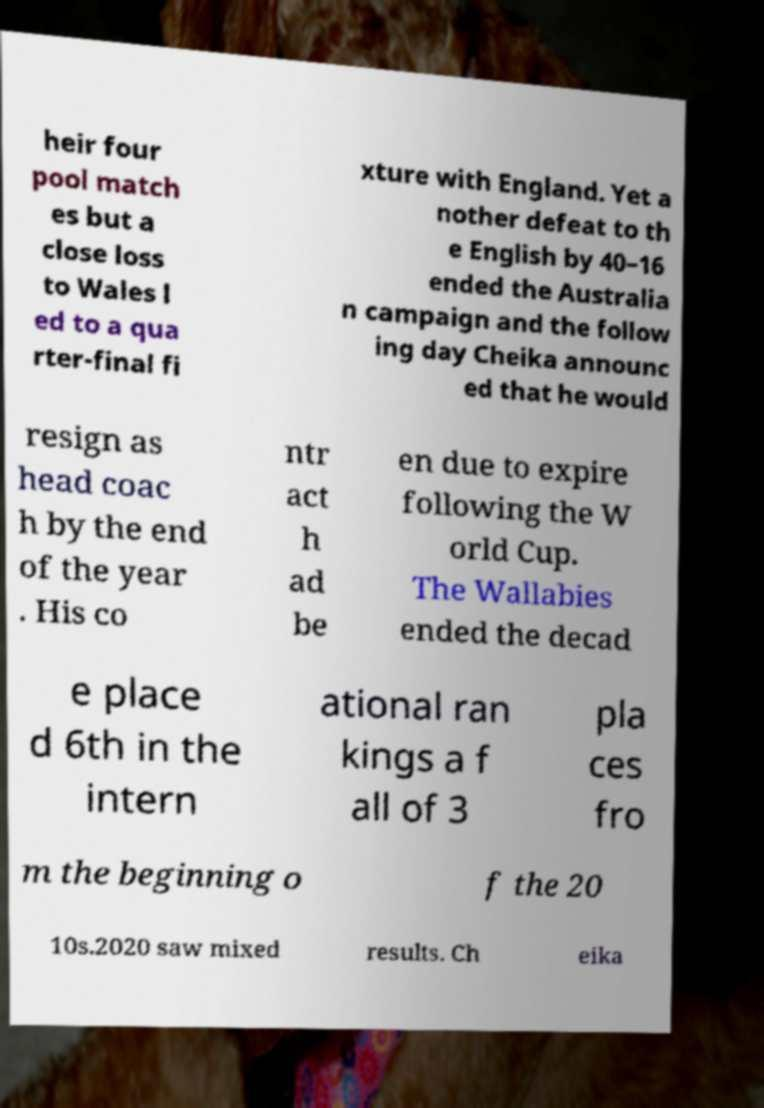Can you read and provide the text displayed in the image?This photo seems to have some interesting text. Can you extract and type it out for me? heir four pool match es but a close loss to Wales l ed to a qua rter-final fi xture with England. Yet a nother defeat to th e English by 40–16 ended the Australia n campaign and the follow ing day Cheika announc ed that he would resign as head coac h by the end of the year . His co ntr act h ad be en due to expire following the W orld Cup. The Wallabies ended the decad e place d 6th in the intern ational ran kings a f all of 3 pla ces fro m the beginning o f the 20 10s.2020 saw mixed results. Ch eika 